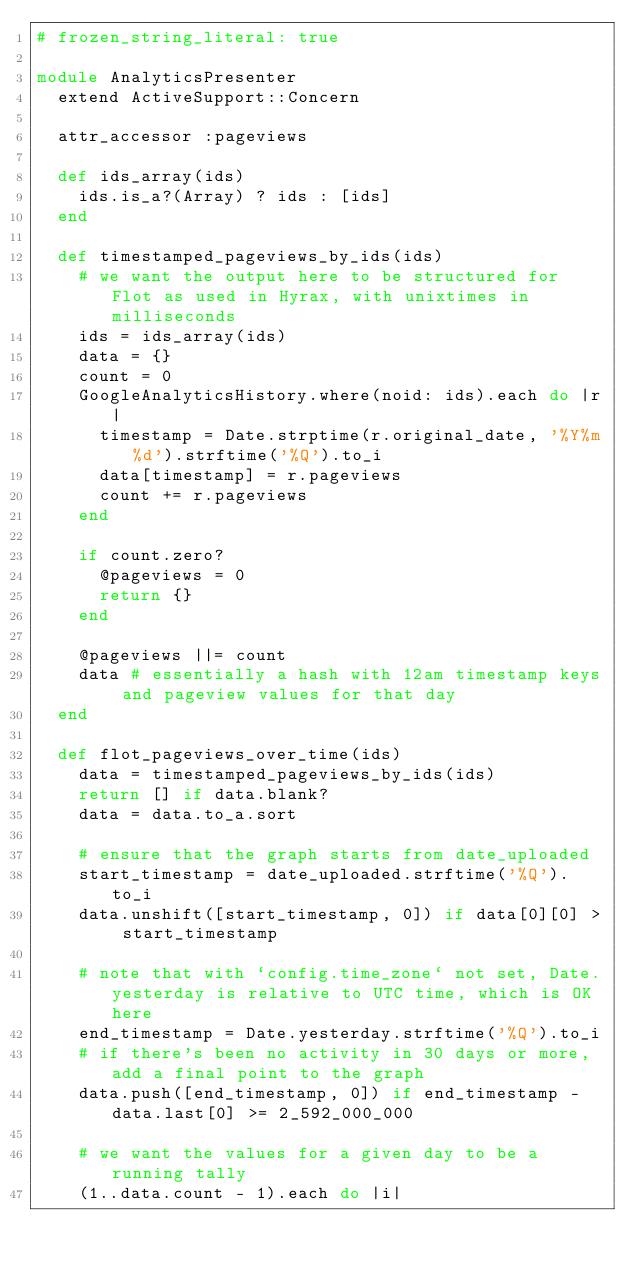Convert code to text. <code><loc_0><loc_0><loc_500><loc_500><_Ruby_># frozen_string_literal: true

module AnalyticsPresenter
  extend ActiveSupport::Concern

  attr_accessor :pageviews

  def ids_array(ids)
    ids.is_a?(Array) ? ids : [ids]
  end

  def timestamped_pageviews_by_ids(ids)
    # we want the output here to be structured for Flot as used in Hyrax, with unixtimes in milliseconds
    ids = ids_array(ids)
    data = {}
    count = 0
    GoogleAnalyticsHistory.where(noid: ids).each do |r|
      timestamp = Date.strptime(r.original_date, '%Y%m%d').strftime('%Q').to_i
      data[timestamp] = r.pageviews
      count += r.pageviews
    end

    if count.zero?
      @pageviews = 0
      return {}
    end

    @pageviews ||= count
    data # essentially a hash with 12am timestamp keys and pageview values for that day
  end

  def flot_pageviews_over_time(ids)
    data = timestamped_pageviews_by_ids(ids)
    return [] if data.blank?
    data = data.to_a.sort

    # ensure that the graph starts from date_uploaded
    start_timestamp = date_uploaded.strftime('%Q').to_i
    data.unshift([start_timestamp, 0]) if data[0][0] > start_timestamp

    # note that with `config.time_zone` not set, Date.yesterday is relative to UTC time, which is OK here
    end_timestamp = Date.yesterday.strftime('%Q').to_i
    # if there's been no activity in 30 days or more, add a final point to the graph
    data.push([end_timestamp, 0]) if end_timestamp - data.last[0] >= 2_592_000_000

    # we want the values for a given day to be a running tally
    (1..data.count - 1).each do |i|</code> 